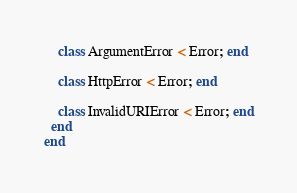Convert code to text. <code><loc_0><loc_0><loc_500><loc_500><_Ruby_>
    class ArgumentError < Error; end

    class HttpError < Error; end

    class InvalidURIError < Error; end
  end
end
</code> 